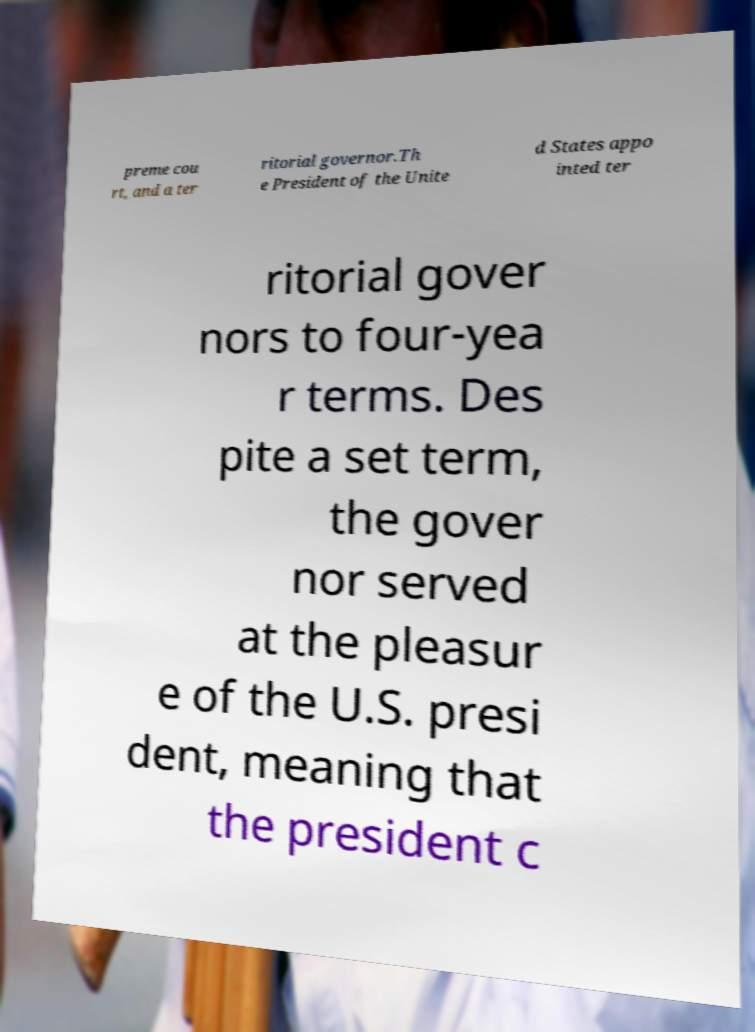Please identify and transcribe the text found in this image. preme cou rt, and a ter ritorial governor.Th e President of the Unite d States appo inted ter ritorial gover nors to four-yea r terms. Des pite a set term, the gover nor served at the pleasur e of the U.S. presi dent, meaning that the president c 